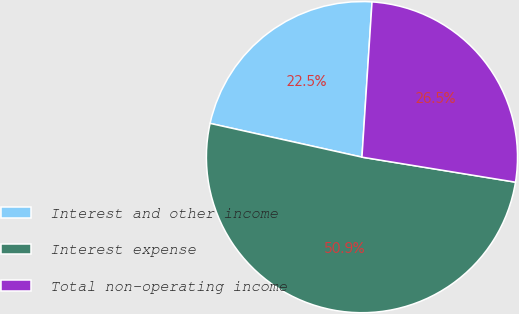Convert chart. <chart><loc_0><loc_0><loc_500><loc_500><pie_chart><fcel>Interest and other income<fcel>Interest expense<fcel>Total non-operating income<nl><fcel>22.55%<fcel>50.91%<fcel>26.54%<nl></chart> 